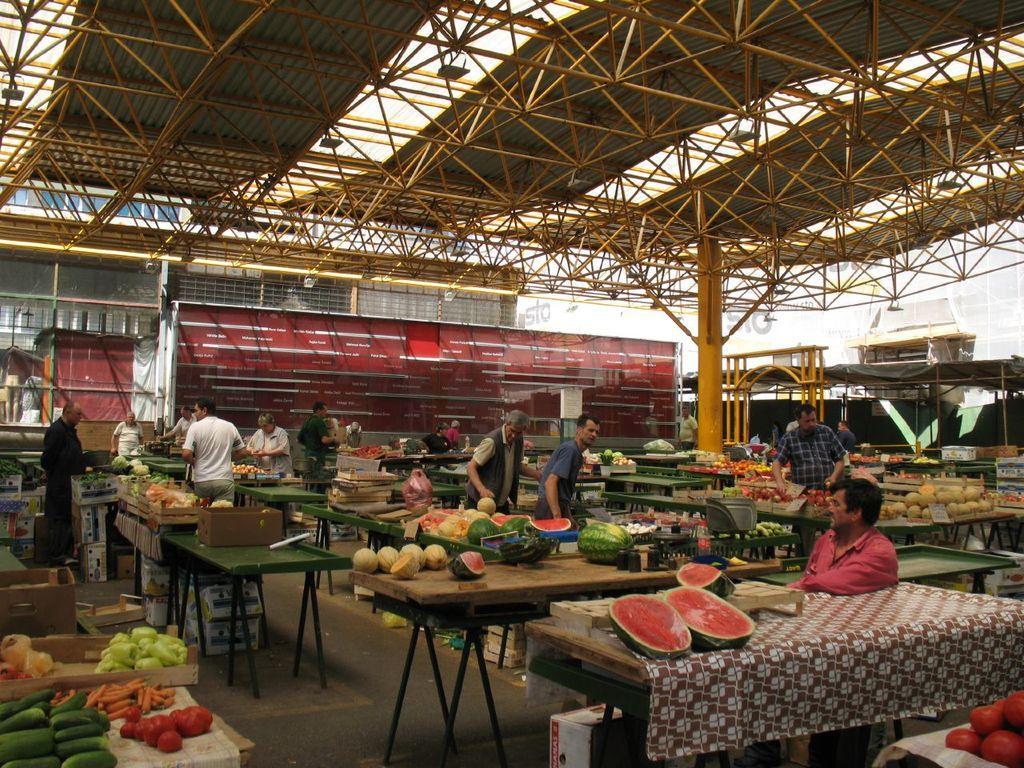In one or two sentences, can you explain what this image depicts? In this picture we can see a group of people standing on the floor, tables with vegetables, fruits, boxes, clothes on it and in the background we can see rods, walls, pillar, arch and some objects. 